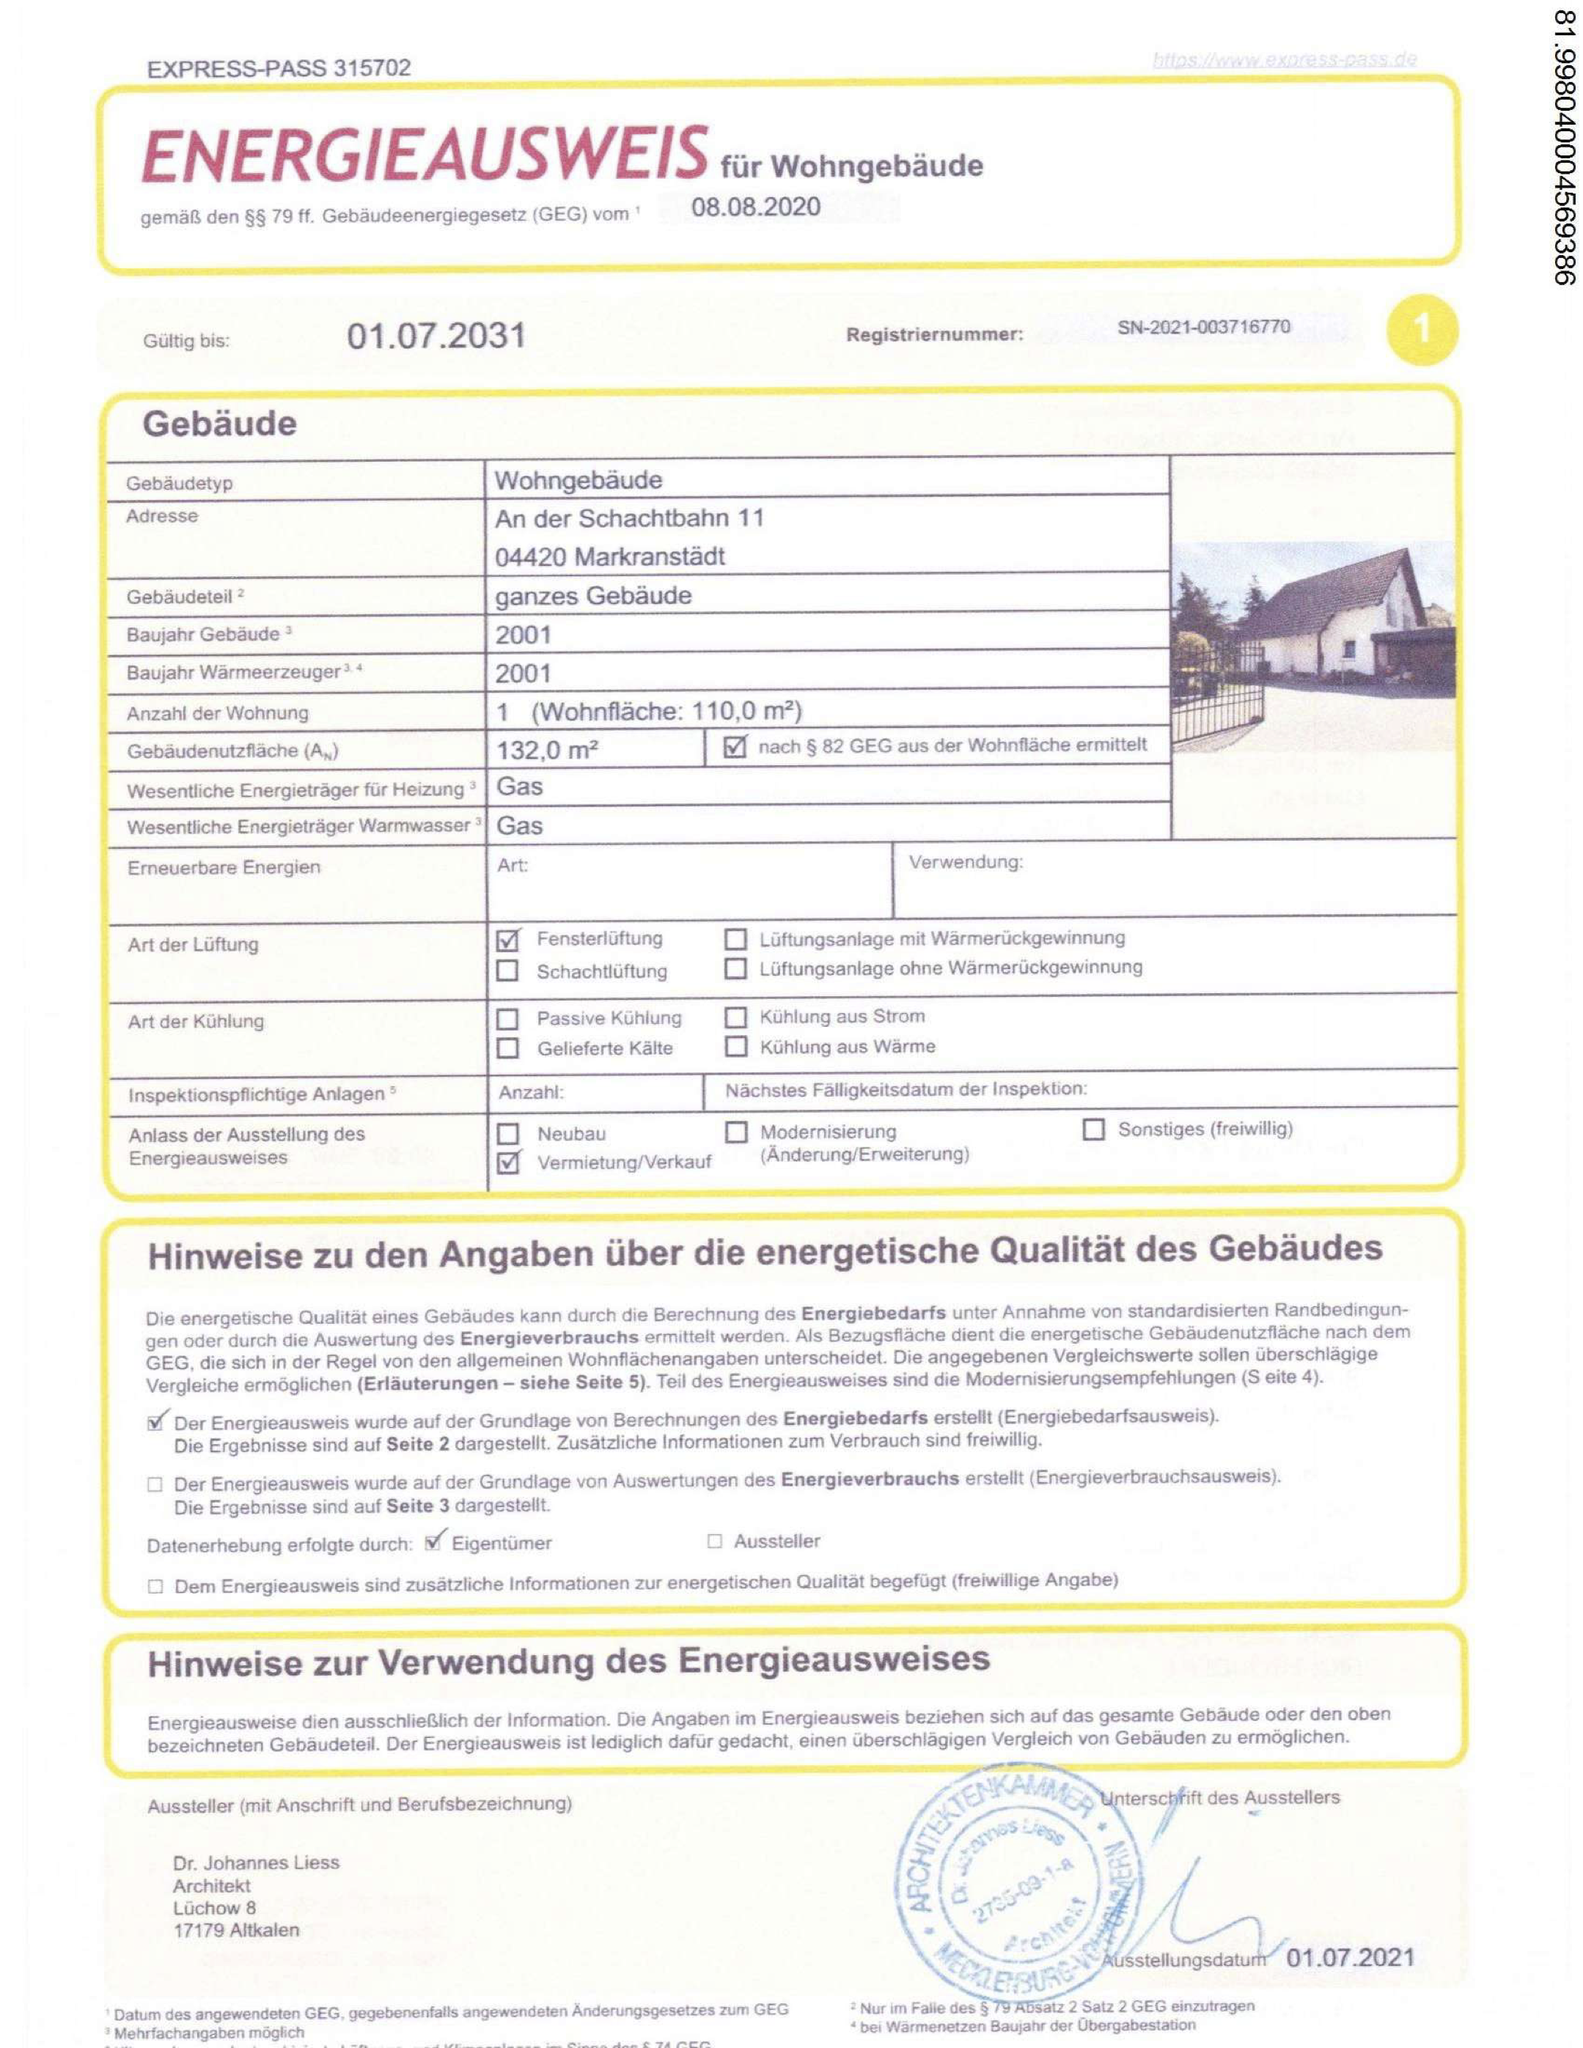Was ist die Wohnfläche? Die Wohnfläche des Gebäudes, das in dem Energieausweis angegeben ist, beträgt 110,0 m². 